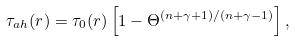<formula> <loc_0><loc_0><loc_500><loc_500>\tau _ { a h } ( r ) = \tau _ { 0 } ( r ) \left [ 1 - \Theta ^ { { ( n + \gamma + 1 ) } / { ( n + \gamma - 1 ) } } \right ] ,</formula> 